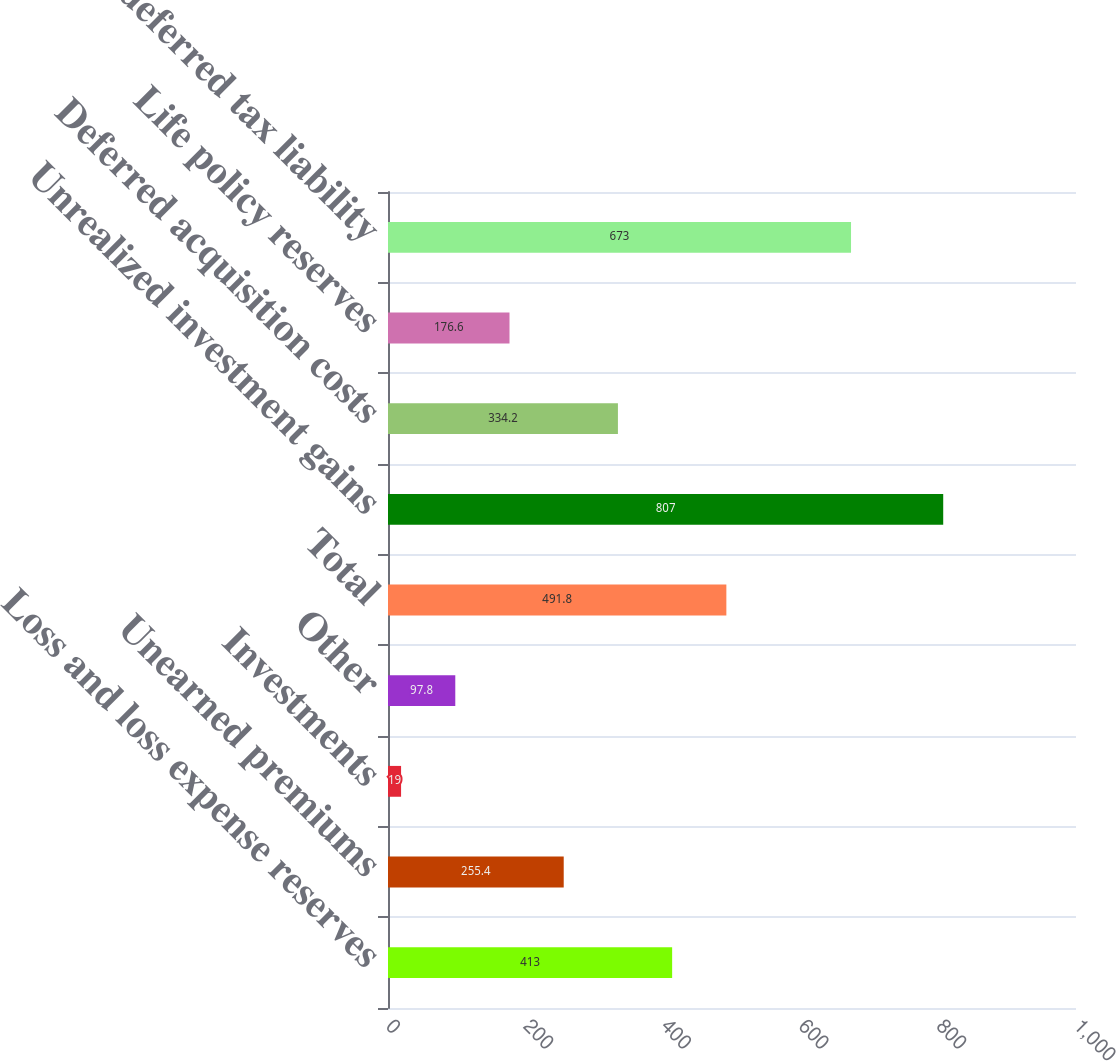Convert chart. <chart><loc_0><loc_0><loc_500><loc_500><bar_chart><fcel>Loss and loss expense reserves<fcel>Unearned premiums<fcel>Investments<fcel>Other<fcel>Total<fcel>Unrealized investment gains<fcel>Deferred acquisition costs<fcel>Life policy reserves<fcel>Net deferred tax liability<nl><fcel>413<fcel>255.4<fcel>19<fcel>97.8<fcel>491.8<fcel>807<fcel>334.2<fcel>176.6<fcel>673<nl></chart> 